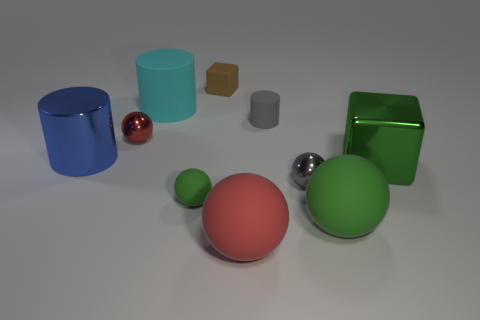Subtract all gray balls. How many balls are left? 4 Subtract all big green rubber balls. How many balls are left? 4 Subtract all blue balls. Subtract all red blocks. How many balls are left? 5 Subtract all cubes. How many objects are left? 8 Add 9 cyan matte balls. How many cyan matte balls exist? 9 Subtract 1 brown cubes. How many objects are left? 9 Subtract all metallic cylinders. Subtract all small red shiny things. How many objects are left? 8 Add 9 gray rubber cylinders. How many gray rubber cylinders are left? 10 